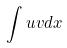Convert formula to latex. <formula><loc_0><loc_0><loc_500><loc_500>\int u v d x</formula> 